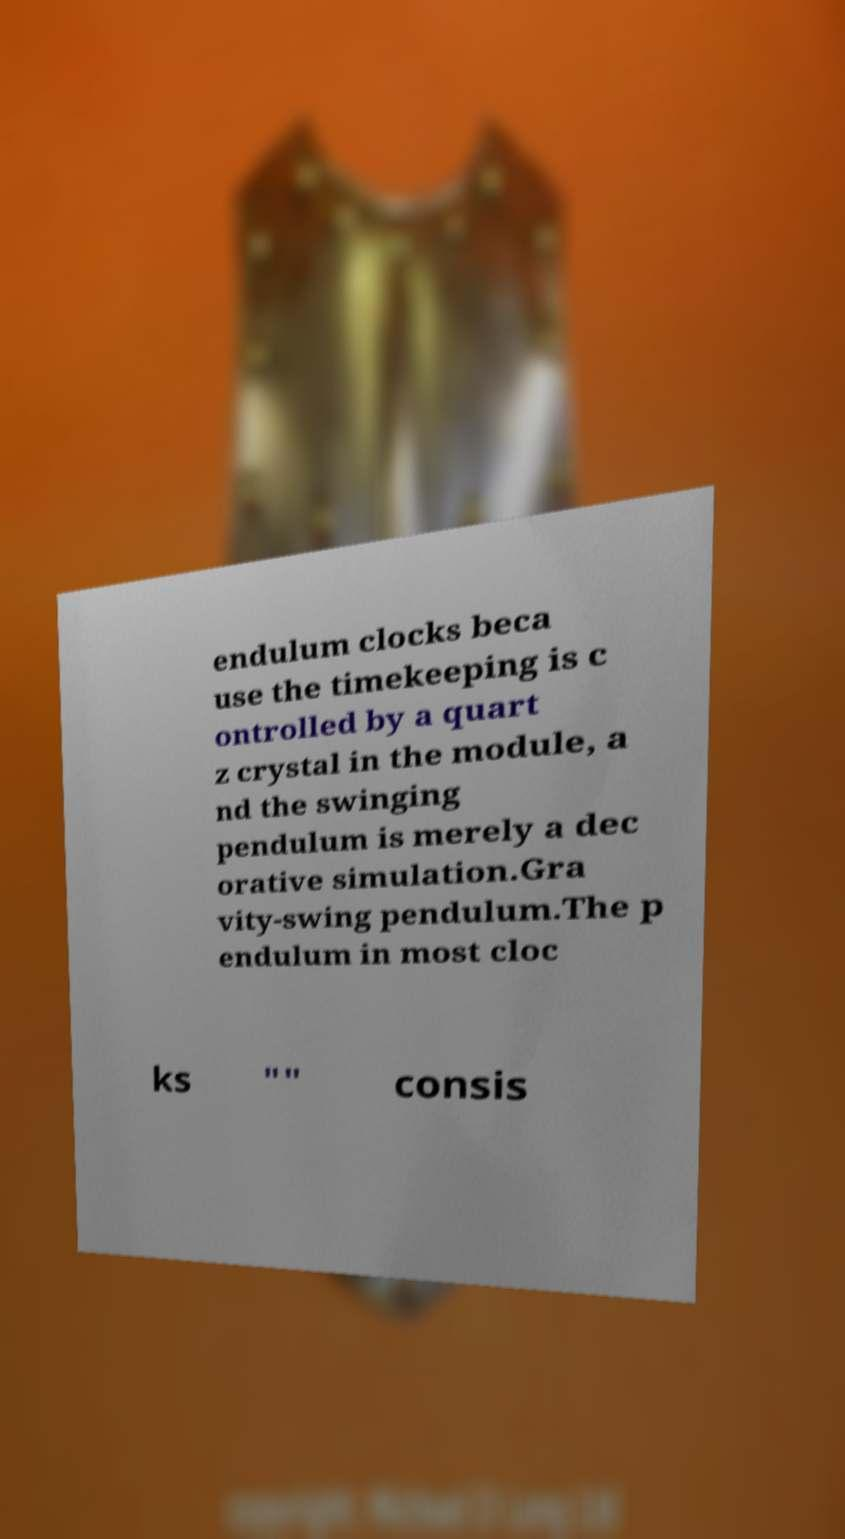Please read and relay the text visible in this image. What does it say? endulum clocks beca use the timekeeping is c ontrolled by a quart z crystal in the module, a nd the swinging pendulum is merely a dec orative simulation.Gra vity-swing pendulum.The p endulum in most cloc ks "" consis 